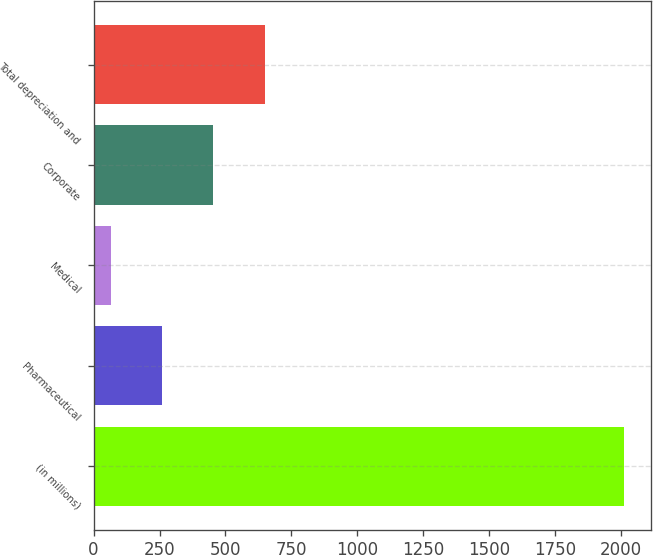Convert chart to OTSL. <chart><loc_0><loc_0><loc_500><loc_500><bar_chart><fcel>(in millions)<fcel>Pharmaceutical<fcel>Medical<fcel>Corporate<fcel>Total depreciation and<nl><fcel>2011<fcel>259.33<fcel>64.7<fcel>453.96<fcel>648.59<nl></chart> 